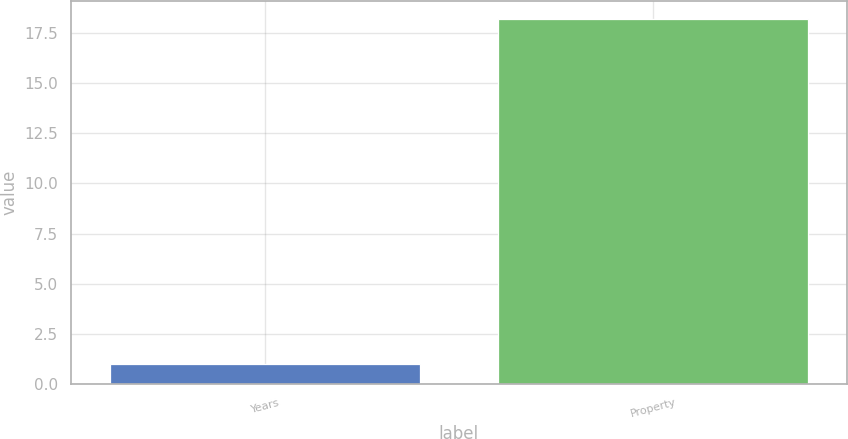<chart> <loc_0><loc_0><loc_500><loc_500><bar_chart><fcel>Years<fcel>Property<nl><fcel>1<fcel>18.2<nl></chart> 